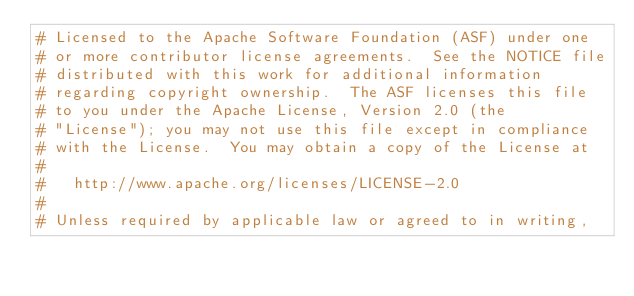<code> <loc_0><loc_0><loc_500><loc_500><_Cython_># Licensed to the Apache Software Foundation (ASF) under one
# or more contributor license agreements.  See the NOTICE file
# distributed with this work for additional information
# regarding copyright ownership.  The ASF licenses this file
# to you under the Apache License, Version 2.0 (the
# "License"); you may not use this file except in compliance
# with the License.  You may obtain a copy of the License at
#
#   http://www.apache.org/licenses/LICENSE-2.0
#
# Unless required by applicable law or agreed to in writing,</code> 